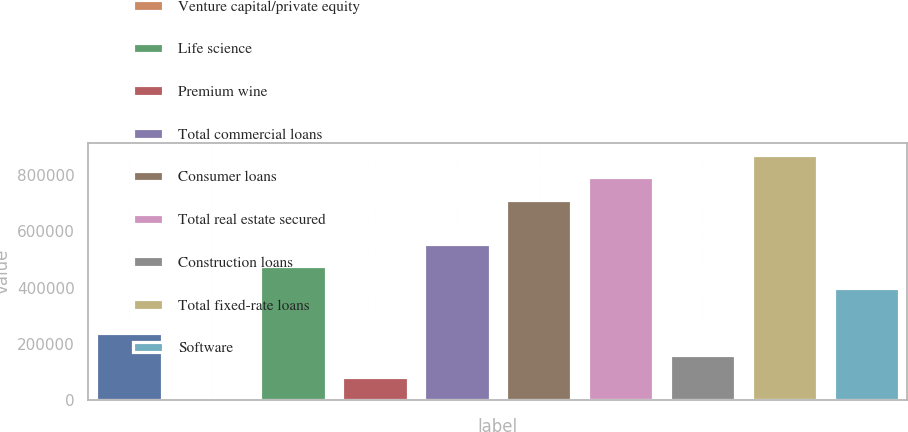<chart> <loc_0><loc_0><loc_500><loc_500><bar_chart><fcel>Hardware<fcel>Venture capital/private equity<fcel>Life science<fcel>Premium wine<fcel>Total commercial loans<fcel>Consumer loans<fcel>Total real estate secured<fcel>Construction loans<fcel>Total fixed-rate loans<fcel>Software<nl><fcel>238520<fcel>900<fcel>476141<fcel>80106.8<fcel>555348<fcel>713761<fcel>792968<fcel>159314<fcel>872175<fcel>396934<nl></chart> 